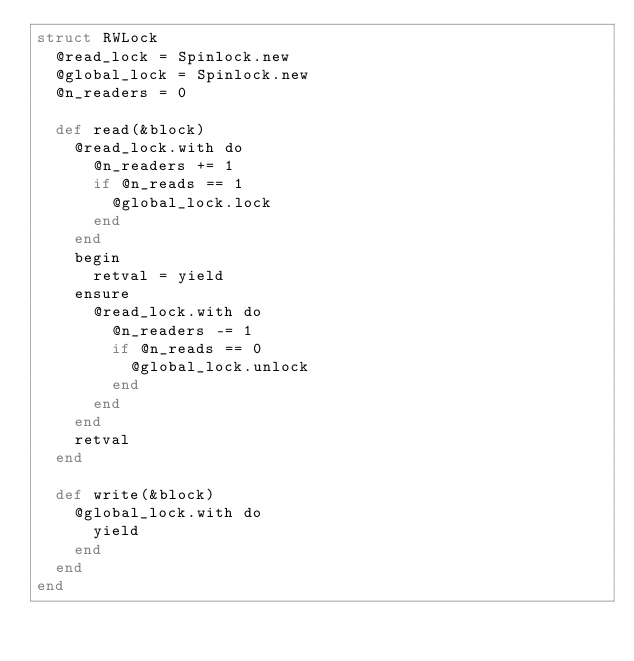Convert code to text. <code><loc_0><loc_0><loc_500><loc_500><_Crystal_>struct RWLock
  @read_lock = Spinlock.new
  @global_lock = Spinlock.new
  @n_readers = 0

  def read(&block)
    @read_lock.with do
      @n_readers += 1
      if @n_reads == 1
        @global_lock.lock
      end
    end
    begin
      retval = yield
    ensure
      @read_lock.with do
        @n_readers -= 1
        if @n_reads == 0
          @global_lock.unlock
        end
      end
    end
    retval
  end

  def write(&block)
    @global_lock.with do
      yield
    end
  end
end
</code> 